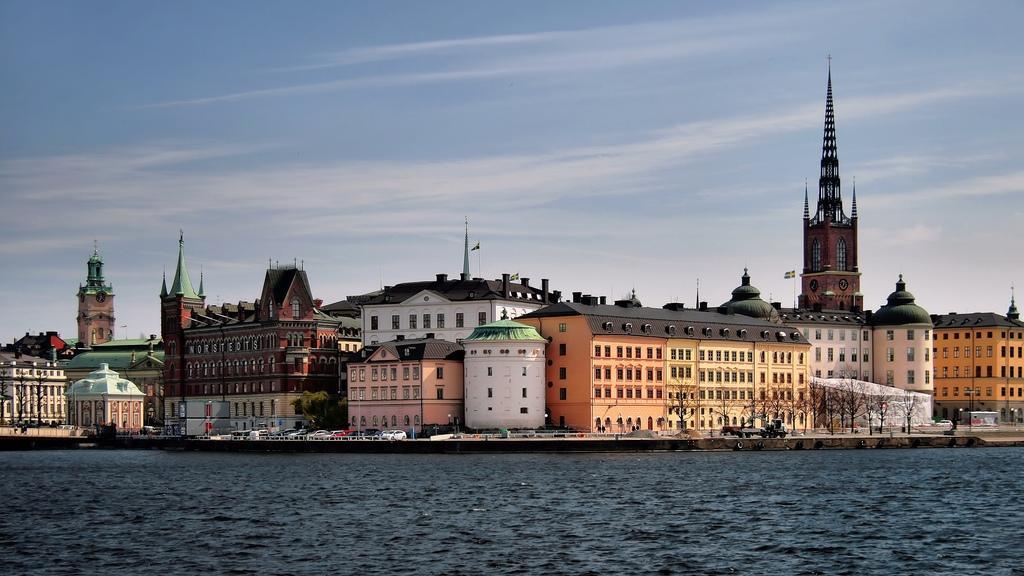Please provide a concise description of this image. In the foreground of the image we can see water body. In the middle of the image we can see building, cars and the road. On the top of the image we can see the sky. 